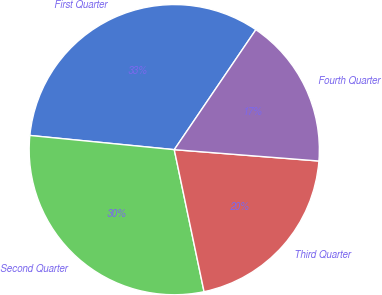Convert chart. <chart><loc_0><loc_0><loc_500><loc_500><pie_chart><fcel>First Quarter<fcel>Second Quarter<fcel>Third Quarter<fcel>Fourth Quarter<nl><fcel>32.94%<fcel>29.85%<fcel>20.46%<fcel>16.74%<nl></chart> 